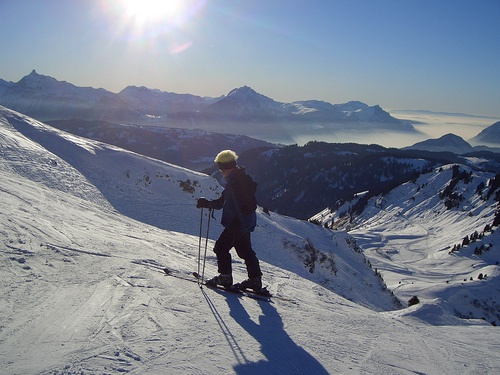Describe the objects in this image and their specific colors. I can see people in gray, black, and darkgray tones and skis in gray, black, darkgray, and navy tones in this image. 